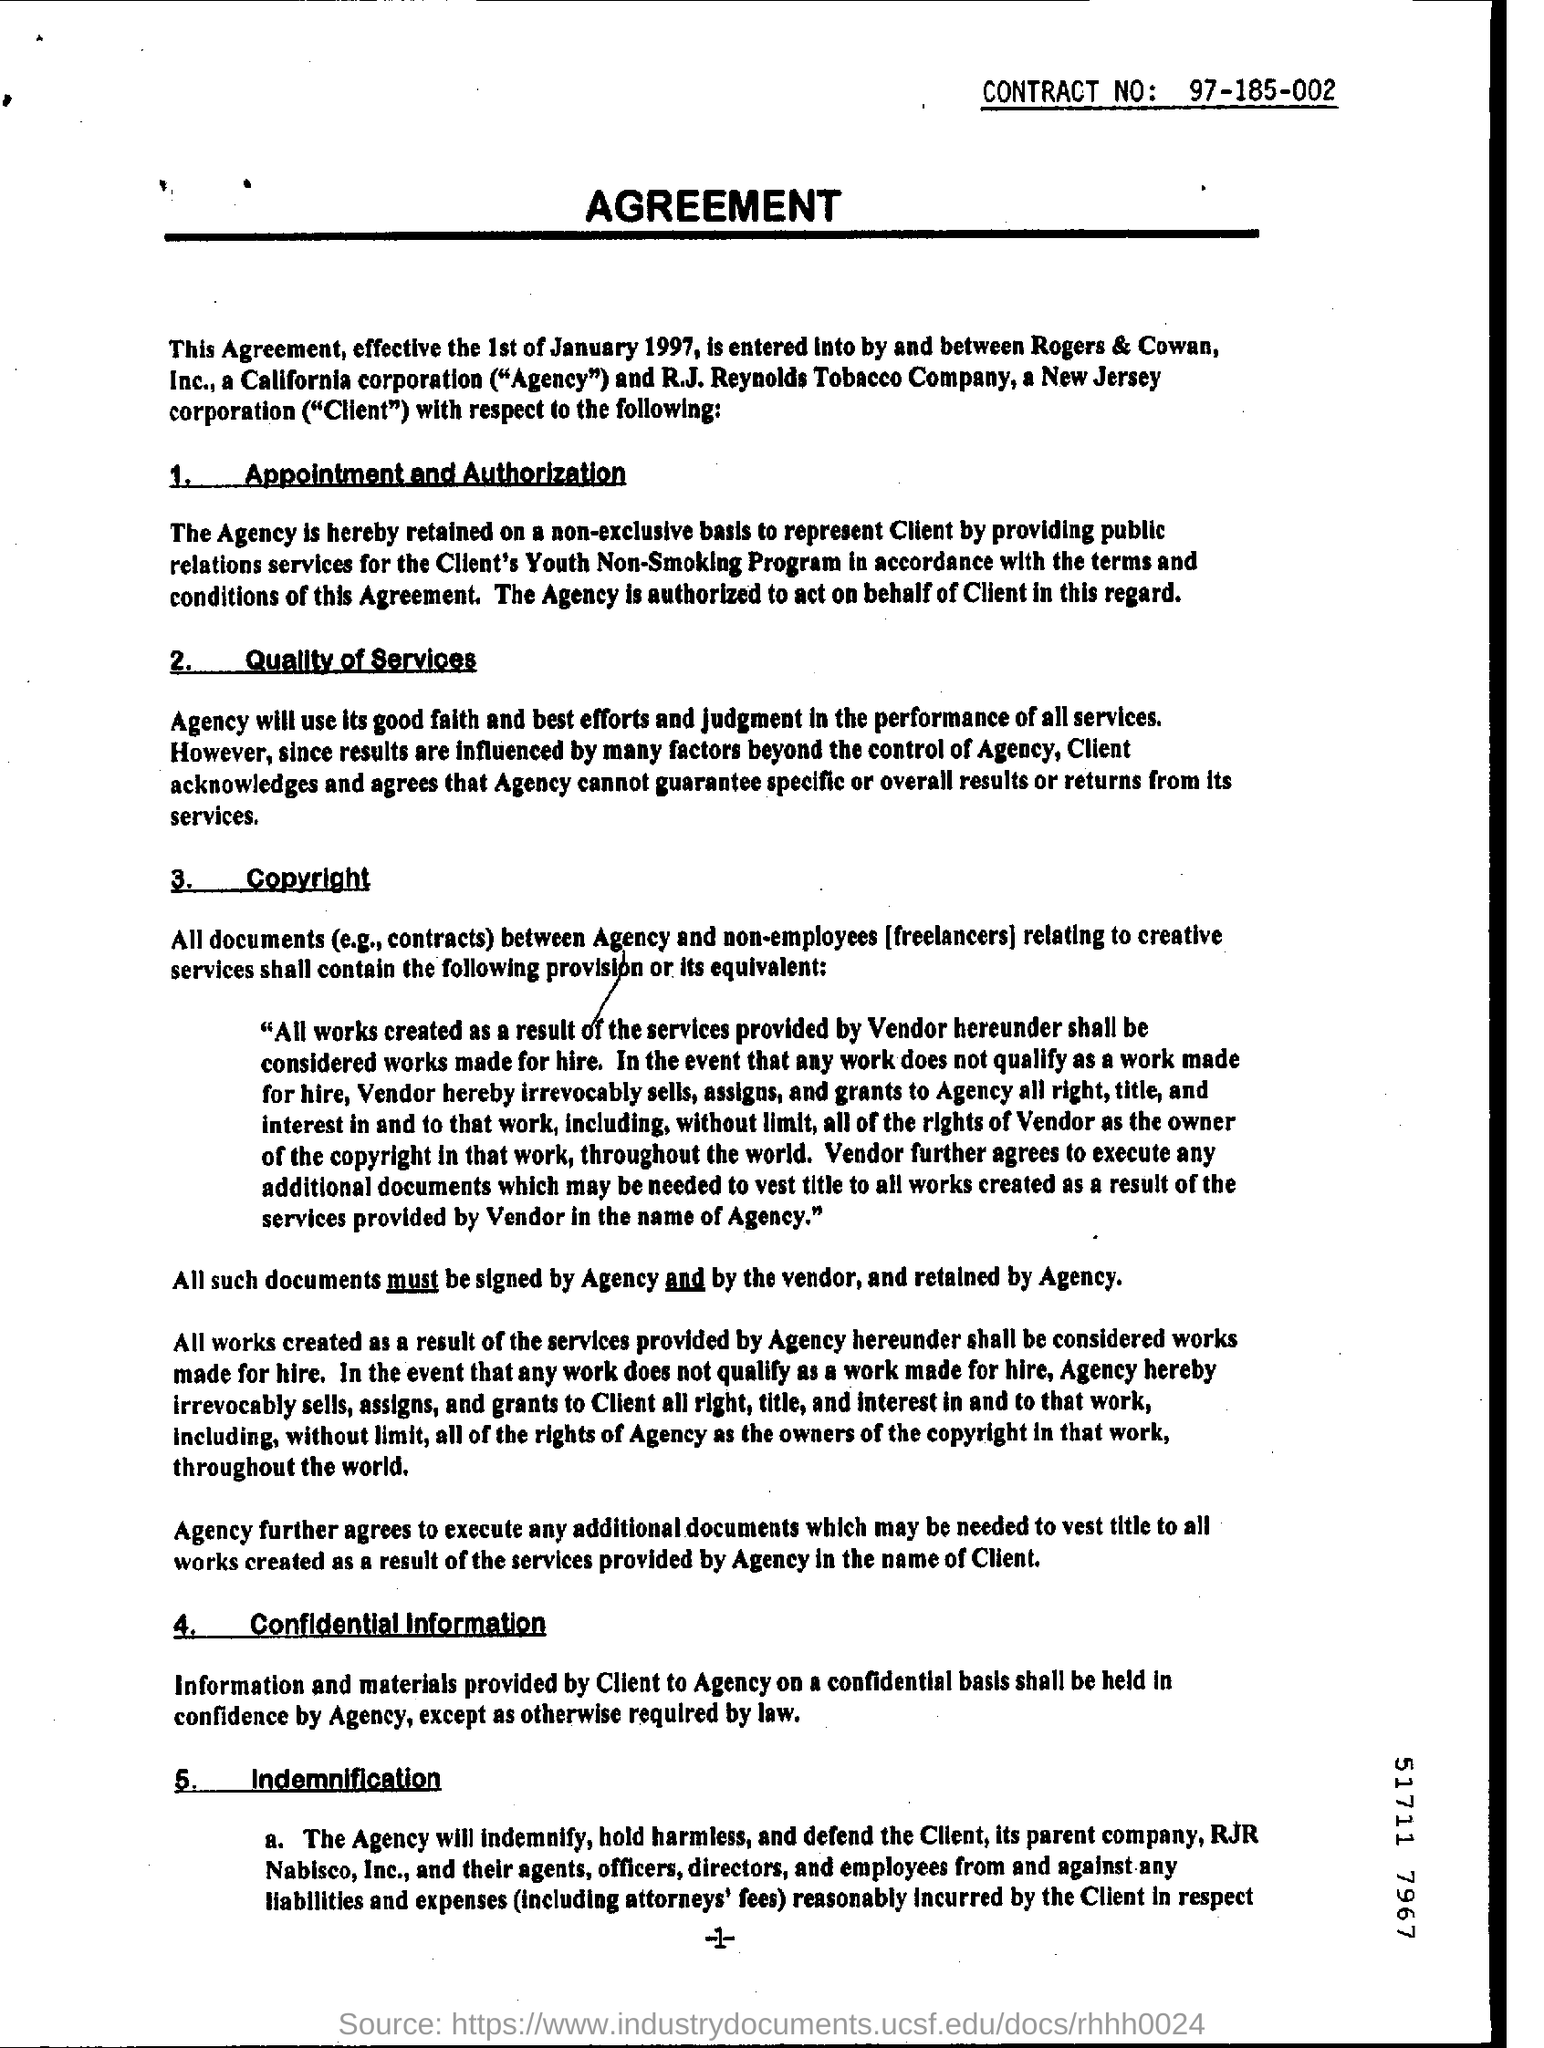Highlight a few significant elements in this photo. The date mentioned in the first sentence is 1st of January 1997. 